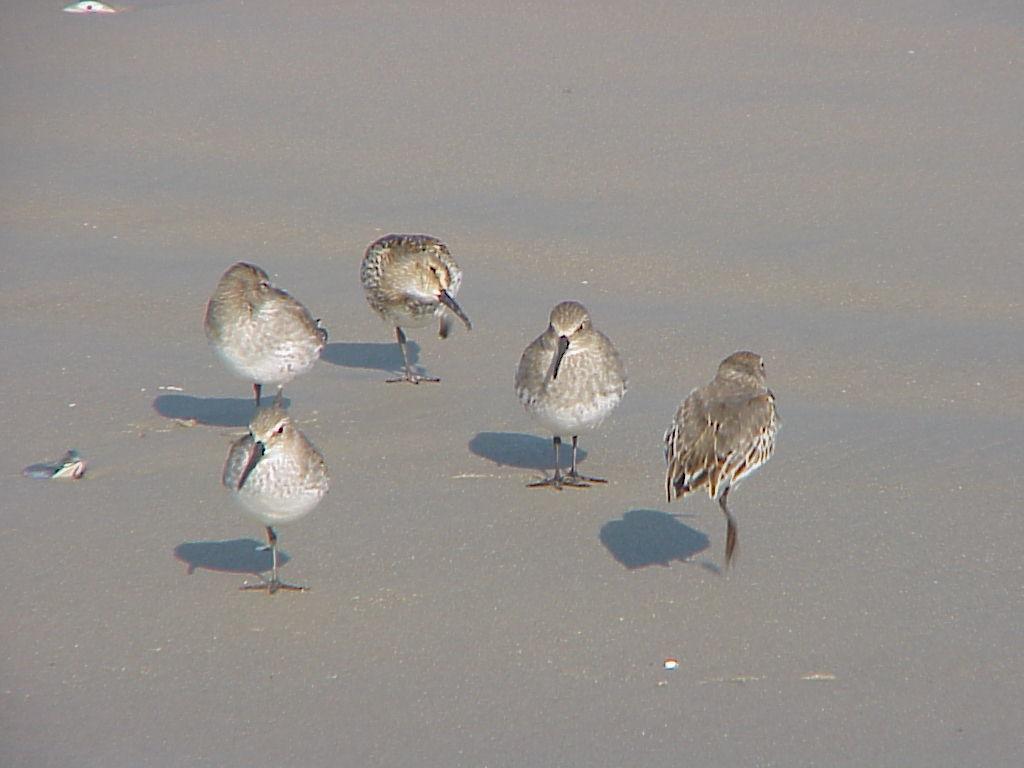In one or two sentences, can you explain what this image depicts? We can see birds standing on the surface. 